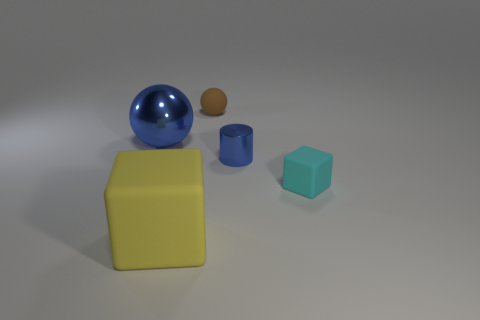There is a matte object behind the tiny cyan cube; is its shape the same as the tiny blue object?
Provide a short and direct response. No. There is a brown ball; is its size the same as the blue metal thing that is right of the big yellow cube?
Provide a succinct answer. Yes. How many other things are the same color as the tiny metal object?
Provide a succinct answer. 1. Are there any matte blocks left of the blue sphere?
Give a very brief answer. No. How many objects are small purple spheres or objects on the right side of the metallic ball?
Your answer should be compact. 4. There is a large blue metal object that is to the left of the matte ball; is there a big matte object to the right of it?
Provide a succinct answer. Yes. What shape is the metal thing that is right of the matte object in front of the tiny matte object that is in front of the tiny sphere?
Provide a succinct answer. Cylinder. What is the color of the rubber thing that is in front of the tiny brown object and behind the big matte block?
Your answer should be very brief. Cyan. The metal object in front of the big blue thing has what shape?
Keep it short and to the point. Cylinder. What is the shape of the cyan thing that is the same material as the big yellow cube?
Keep it short and to the point. Cube. 